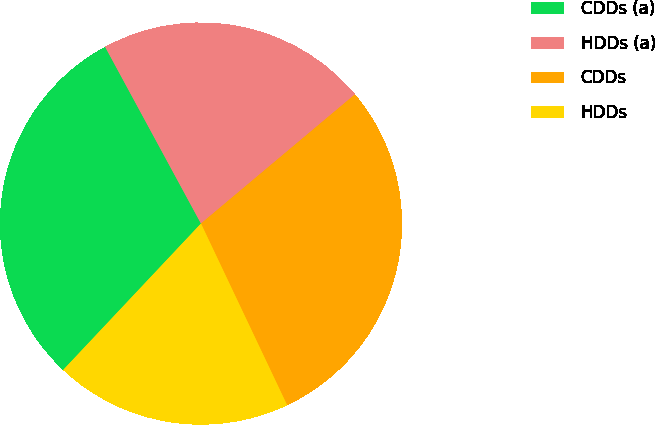Convert chart to OTSL. <chart><loc_0><loc_0><loc_500><loc_500><pie_chart><fcel>CDDs (a)<fcel>HDDs (a)<fcel>CDDs<fcel>HDDs<nl><fcel>30.07%<fcel>21.8%<fcel>29.06%<fcel>19.07%<nl></chart> 